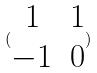<formula> <loc_0><loc_0><loc_500><loc_500>( \begin{matrix} 1 & 1 \\ - 1 & 0 \end{matrix} )</formula> 